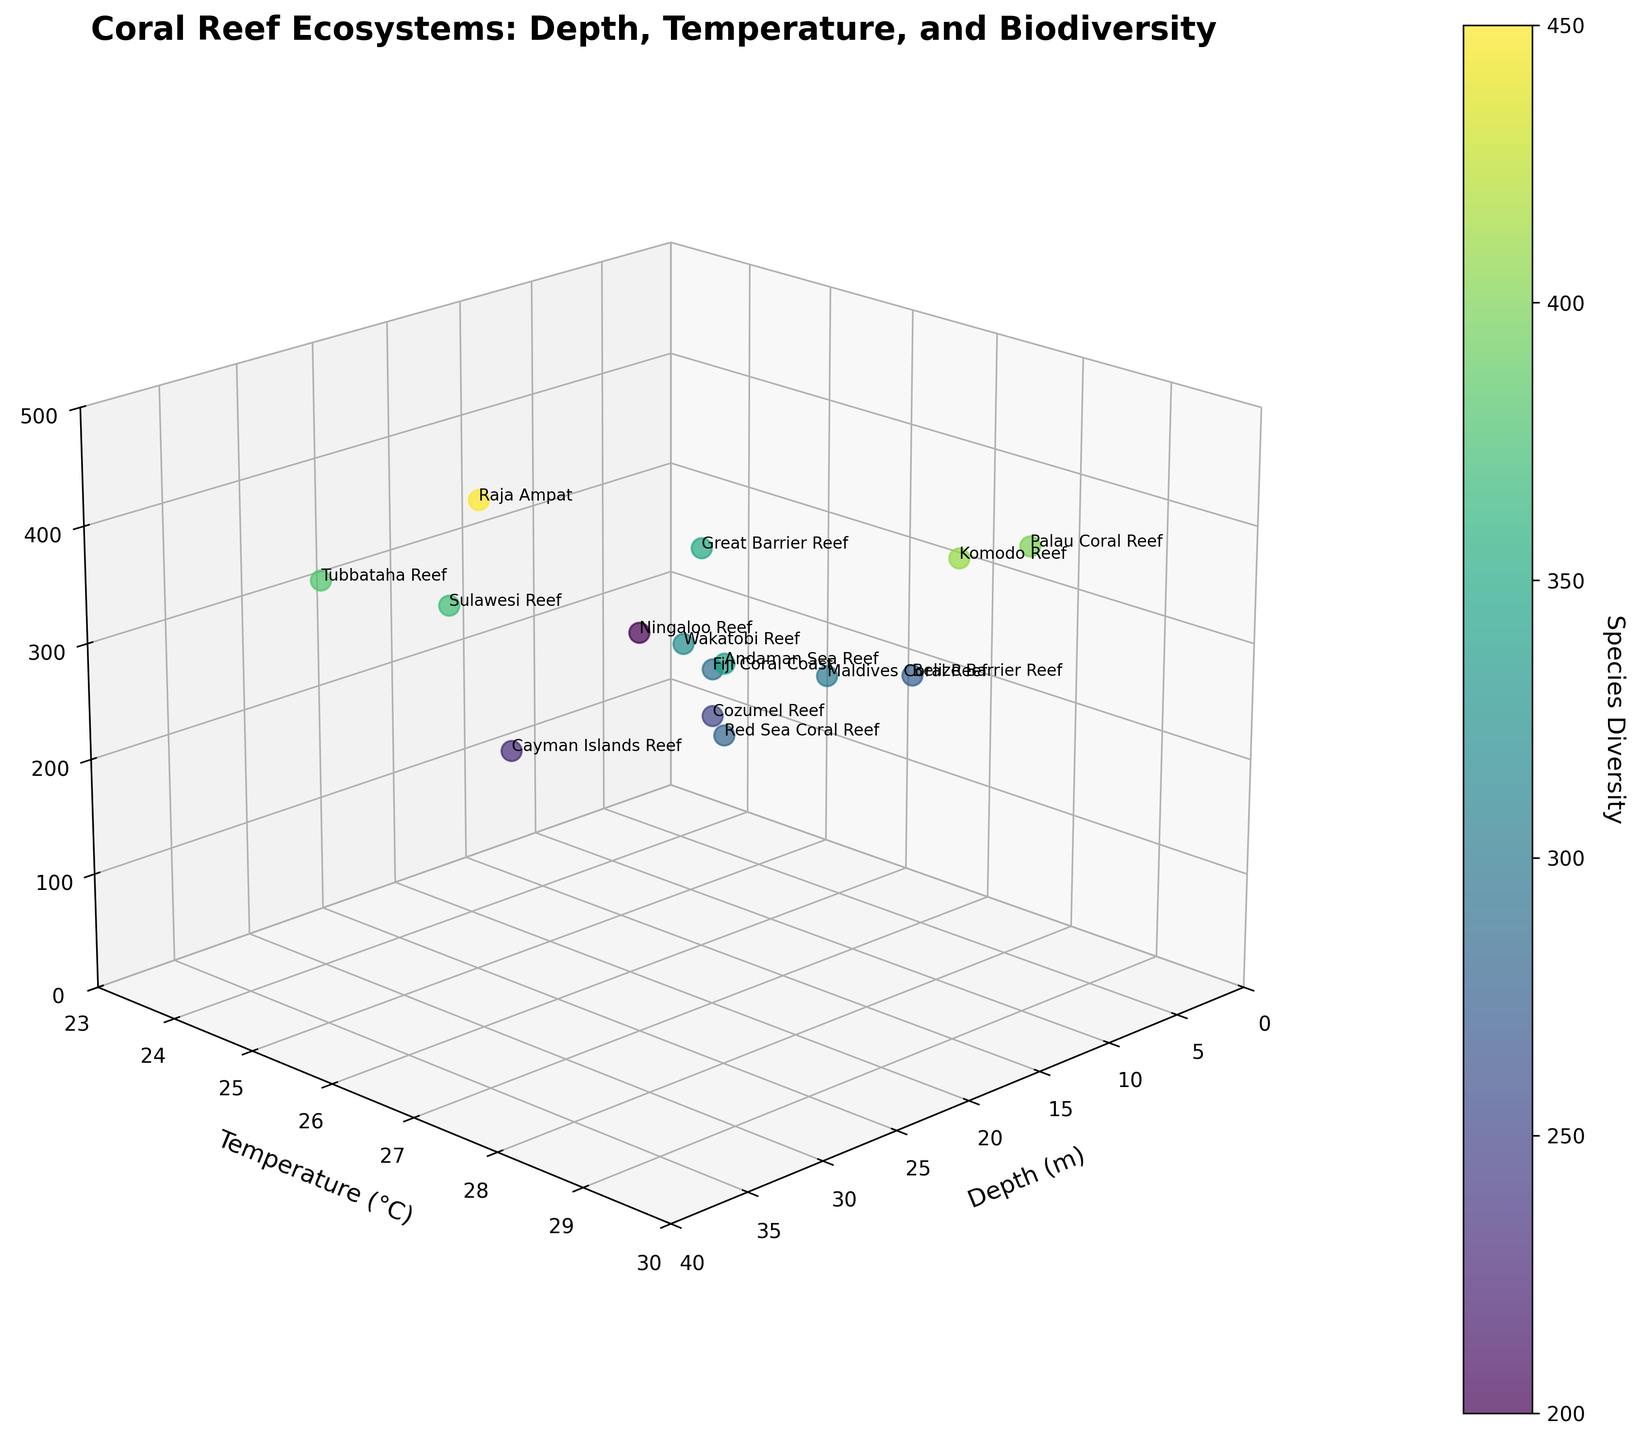What is the title of the plot? The title is displayed at the top of the figure and provides a summary of the graph's subject. The title reads "Coral Reef Ecosystems: Depth, Temperature, and Biodiversity."
Answer: Coral Reef Ecosystems: Depth, Temperature, and Biodiversity How many data points are plotted in the figure? By counting the number of coral reef names listed in the data and corresponding points in the plot, we find there are 15 data points.
Answer: 15 What do the colors of the data points represent? The color of each data point is determined by a color bar, indicating species diversity, with the 'viridis' colormap used for visualization.
Answer: Species Diversity What does the x-axis represent in the plot? The x-axis label indicates that it represents the depth of the coral reefs in meters.
Answer: Depth (m) What does the y-axis represent in the plot? The y-axis label shows that it represents the water temperature of the coral reefs in degrees Celsius.
Answer: Temperature (°C) What is the sum of species diversity for Palau Coral Reef and Great Barrier Reef? The species diversity values for Palau Coral Reef and Great Barrier Reef are 400 and 350, respectively. Adding these values gives 400 + 350 = 750.
Answer: 750 What is the average depth of Tubbataha Reef and Sulawesi Reef? The depths of Tubbataha Reef and Sulawesi Reef are 35 and 32 meters, respectively. Their average depth is (35 + 32) / 2 = 33.5 meters.
Answer: 33.5 meters What is the range of temperatures shown in the plot? The minimum temperature is 24°C at Ningaloo Reef, and the maximum temperature is 29°C at Palau Coral Reef and Komodo Reef. Thus, the range is 29 - 24 = 5°C.
Answer: 5°C Calculate the median species diversity of all the coral reefs. Ordering the species diversity values: 200, 230, 250, 275, 280, 290, 300, 320, 340, 350, 370, 380, 400, 410, 450, the median (middle value) is 320 (Wakatobi Reef).
Answer: 320 Which coral reef has the highest species diversity? By examining the species diversity values, we find that Raja Ampat has the highest species diversity of 450.
Answer: Raja Ampat Which coral reef has the lowest temperature? The figure shows that Ningaloo Reef has the lowest temperature at 24°C.
Answer: Ningaloo Reef Which coral reef is found at the greatest depth? By looking at the depth values, Tubbataha Reef is located at the greatest depth of 35 meters.
Answer: Tubbataha Reef Which two coral reefs have the same temperature but different species diversity? Both Maldives Coral Reef and Belize Barrier Reef have the same temperature of 28°C but have different species diversity values of 300 and 275, respectively.
Answer: Maldives Coral Reef and Belize Barrier Reef What is the overall trend between depth and species diversity? Observing the data points, there seems to be a general trend that higher depths do not necessarily correlate with higher species diversity; the trend is not linear.
Answer: No clear trend Which coral reefs appear to be outliers in terms of species diversity and temperature? Raja Ampat and Komodo Reef have very high species diversity compared to others with similar temperatures, and Ningaloo Reef has unusually low temperature and species diversity.
Answer: Raja Ampat, Komodo Reef, and Ningaloo Reef 